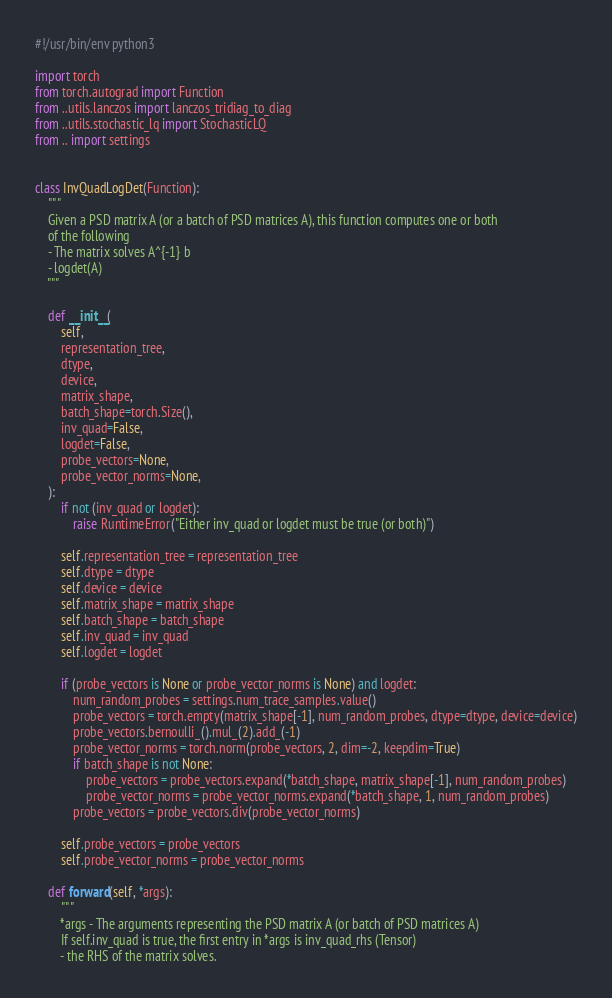Convert code to text. <code><loc_0><loc_0><loc_500><loc_500><_Python_>#!/usr/bin/env python3

import torch
from torch.autograd import Function
from ..utils.lanczos import lanczos_tridiag_to_diag
from ..utils.stochastic_lq import StochasticLQ
from .. import settings


class InvQuadLogDet(Function):
    """
    Given a PSD matrix A (or a batch of PSD matrices A), this function computes one or both
    of the following
    - The matrix solves A^{-1} b
    - logdet(A)
    """

    def __init__(
        self,
        representation_tree,
        dtype,
        device,
        matrix_shape,
        batch_shape=torch.Size(),
        inv_quad=False,
        logdet=False,
        probe_vectors=None,
        probe_vector_norms=None,
    ):
        if not (inv_quad or logdet):
            raise RuntimeError("Either inv_quad or logdet must be true (or both)")

        self.representation_tree = representation_tree
        self.dtype = dtype
        self.device = device
        self.matrix_shape = matrix_shape
        self.batch_shape = batch_shape
        self.inv_quad = inv_quad
        self.logdet = logdet

        if (probe_vectors is None or probe_vector_norms is None) and logdet:
            num_random_probes = settings.num_trace_samples.value()
            probe_vectors = torch.empty(matrix_shape[-1], num_random_probes, dtype=dtype, device=device)
            probe_vectors.bernoulli_().mul_(2).add_(-1)
            probe_vector_norms = torch.norm(probe_vectors, 2, dim=-2, keepdim=True)
            if batch_shape is not None:
                probe_vectors = probe_vectors.expand(*batch_shape, matrix_shape[-1], num_random_probes)
                probe_vector_norms = probe_vector_norms.expand(*batch_shape, 1, num_random_probes)
            probe_vectors = probe_vectors.div(probe_vector_norms)

        self.probe_vectors = probe_vectors
        self.probe_vector_norms = probe_vector_norms

    def forward(self, *args):
        """
        *args - The arguments representing the PSD matrix A (or batch of PSD matrices A)
        If self.inv_quad is true, the first entry in *args is inv_quad_rhs (Tensor)
        - the RHS of the matrix solves.
</code> 